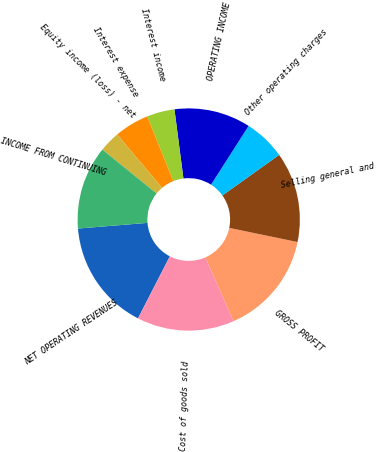Convert chart to OTSL. <chart><loc_0><loc_0><loc_500><loc_500><pie_chart><fcel>NET OPERATING REVENUES<fcel>Cost of goods sold<fcel>GROSS PROFIT<fcel>Selling general and<fcel>Other operating charges<fcel>OPERATING INCOME<fcel>Interest income<fcel>Interest expense<fcel>Equity income (loss) - net<fcel>INCOME FROM CONTINUING<nl><fcel>16.16%<fcel>14.14%<fcel>15.15%<fcel>13.13%<fcel>6.06%<fcel>11.11%<fcel>4.04%<fcel>5.05%<fcel>3.03%<fcel>12.12%<nl></chart> 